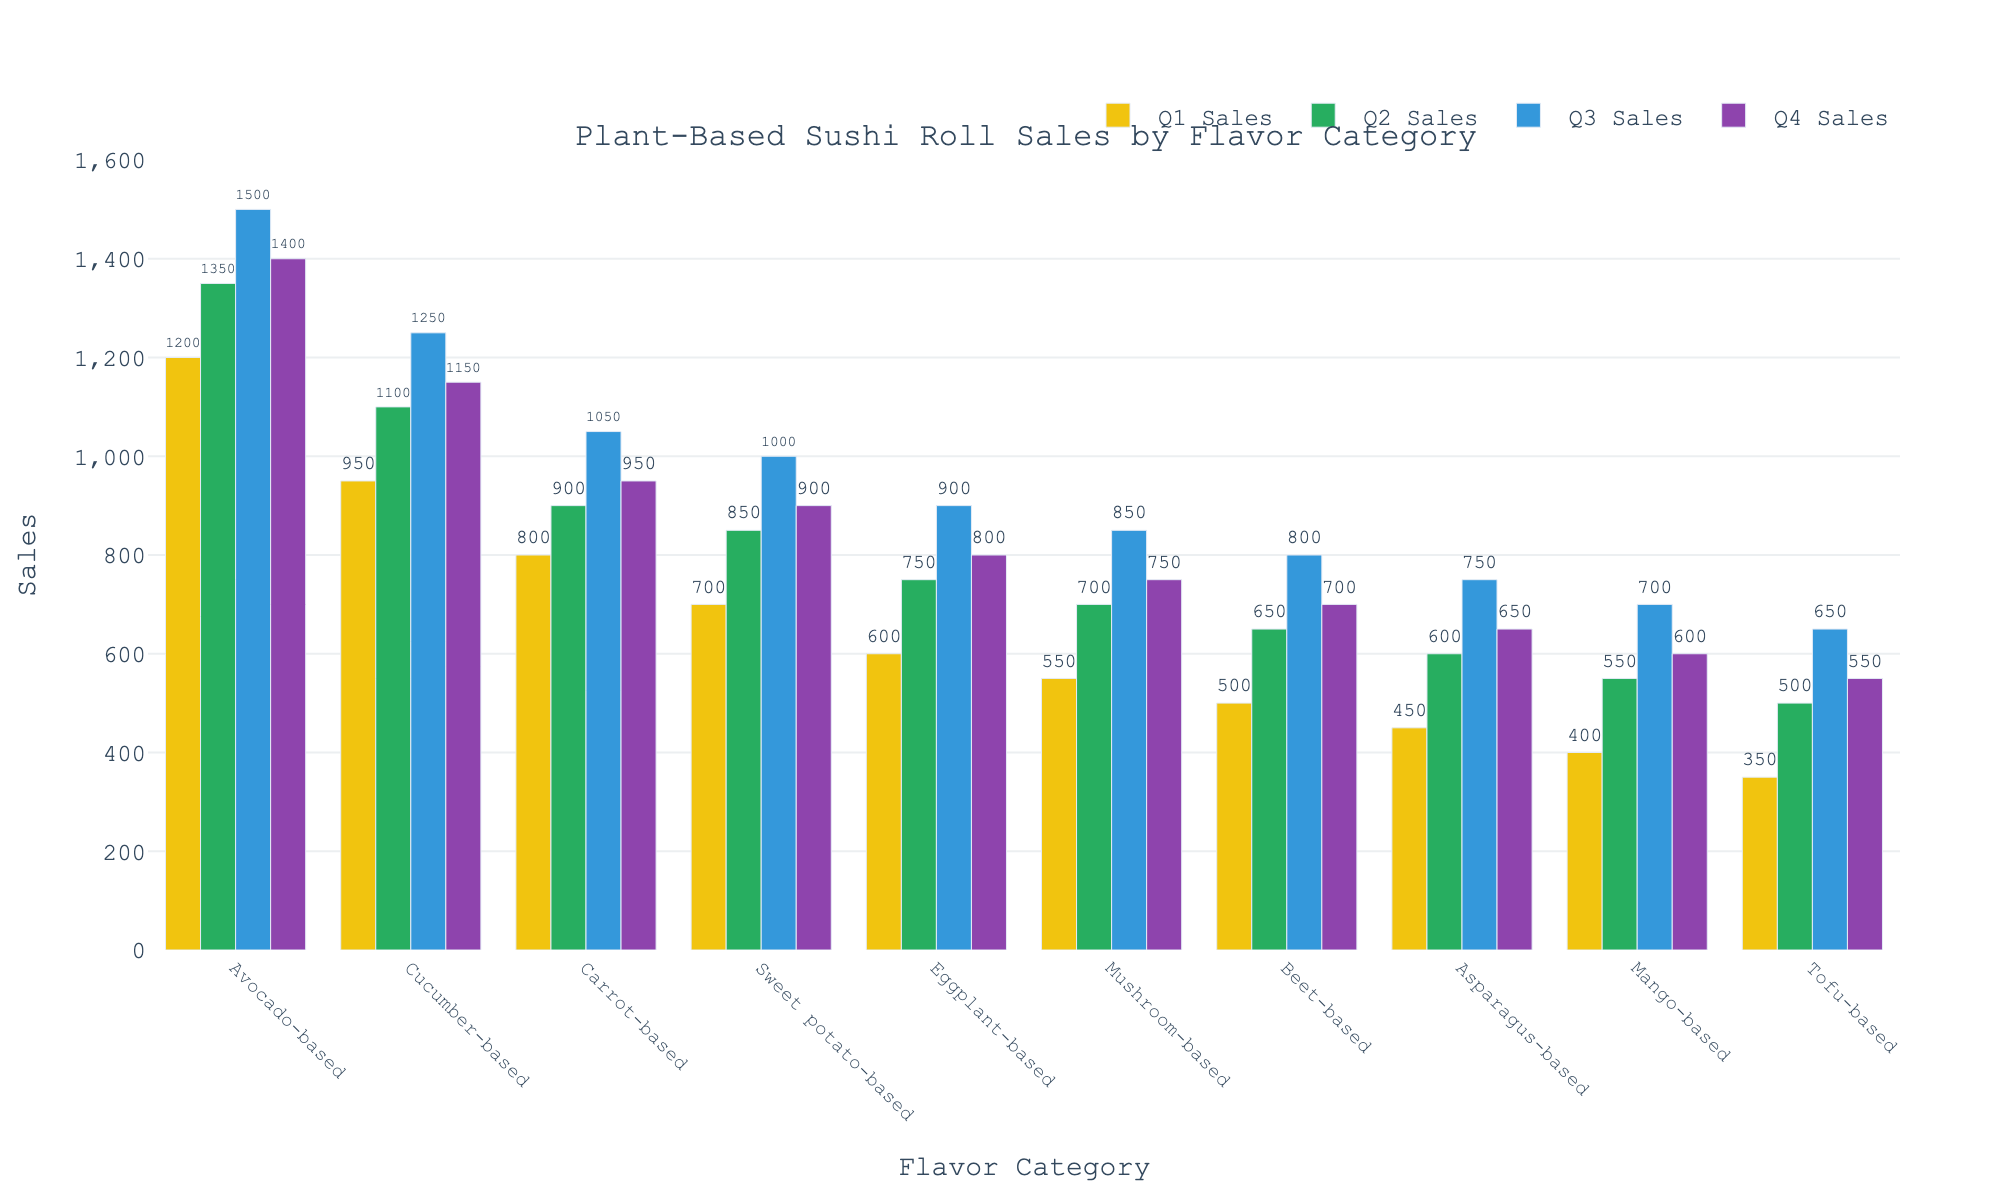Which flavor category had the highest sales in Q3? From the bar chart, we can see the heights of the bars for the Q3 sales. The highest bar in Q3 corresponds to the Avocado-based flavor category.
Answer: Avocado-based Which flavor category had the lowest sales in Q1? By looking at the bar chart for Q1 sales, the shortest bar corresponds to the Tofu-based flavor category.
Answer: Tofu-based How did the sales of Carrot-based sushi rolls change from Q1 to Q4? By examining the bar heights for the Carrot-based category across the quarters: Q1 (800), Q2 (900), Q3 (1050), Q4 (950). Sales increased from Q1 to Q3 and then decreased slightly in Q4.
Answer: Increased overall with slight decrease in Q4 What is the overall trend in sales for the Sweet potato-based category? Observing the bars for Sweet potato-based rolls: Q1 (700), Q2 (850), Q3 (1000), Q4 (900). The sales steadily increased from Q1 to Q3 and then decreased in Q4.
Answer: Increasing until Q3, then slight decrease Which two quarters had the highest sales for the Mushroom-based flavor category? The bars for Mushroom-based sushi rolls show values: Q1 (550), Q2 (700), Q3 (850), Q4 (750). The highest sales are in Q3 and Q4.
Answer: Q3 and Q4 Is the average sales of the Avocado-based flavor category higher than the average sales of the Beet-based category? Calculate the average for both categories: 
Avocado-based (1200 + 1350 + 1500 + 1400)/4 = 1362.5, Beet-based (500 + 650 + 800 + 700)/4 = 662.5. Yes, the average sales of the Avocado-based category is higher.
Answer: Yes By how much did the sales of the Cucumber-based flavor category increase from Q1 to Q3? The sales values for Cucumber-based rolls are Q1 (950), Q2 (1100), Q3 (1250). The increase from Q1 to Q3 is 1250 - 950 = 300.
Answer: 300 Which flavor category had more consistent sales across all quarters: Tofu-based or Mango-based? Look at the sales values and their variation: 
Tofu-based (350, 500, 650, 550), range = 650 - 350 = 300. 
Mango-based (400, 550, 700, 600), range = 700 - 400 = 300. 
Both have the same range of variation.
Answer: Both are equally consistent Between Q2 and Q4, which flavor category showed the highest increase in sales? Calculate the increase in sales from Q2 to Q4 for each category and find the highest one:
Avocado-based (1400 - 1350 = 50), Cucumber-based (1150 - 1100 = 50), Carrot-based (950 - 900 = 50), Sweet potato-based (900 - 850 = 50), Eggplant-based (800 - 750 = 50), Mushroom-based (750 - 700 = 50), Beet-based (700 - 650 = 50), Asparagus-based (650 - 600 = 50), Mango-based (600 - 550 = 50), Tofu-based (550 - 500 = 50). No single category shows the highest increase; all show an equal increase.
Answer: All categories show equal increase Which flavor category had the smallest decrease in sales from Q3 to Q4? Calculate the decrease in sales from Q3 to Q4 for each category:
Avocado-based (1500 - 1400 = 100), Cucumber-based (1250 - 1150 = 100), Carrot-based (1050 - 950 = 100), Sweet potato-based (1000 - 900 = 100), Eggplant-based (900 - 800 = 100), Mushroom-based (850 - 750 = 100), Beet-based (800 - 700 = 100), Asparagus-based (750 - 650 = 100), Mango-based (700 - 600 = 100), Tofu-based (650 - 550 = 100). No single category shows the smallest decrease; all show an equal decrease.
Answer: All categories show equal decrease 